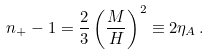Convert formula to latex. <formula><loc_0><loc_0><loc_500><loc_500>n _ { + } - 1 = \frac { 2 } { 3 } \left ( \frac { M } { H } \right ) ^ { 2 } \equiv 2 \eta _ { A } \, .</formula> 